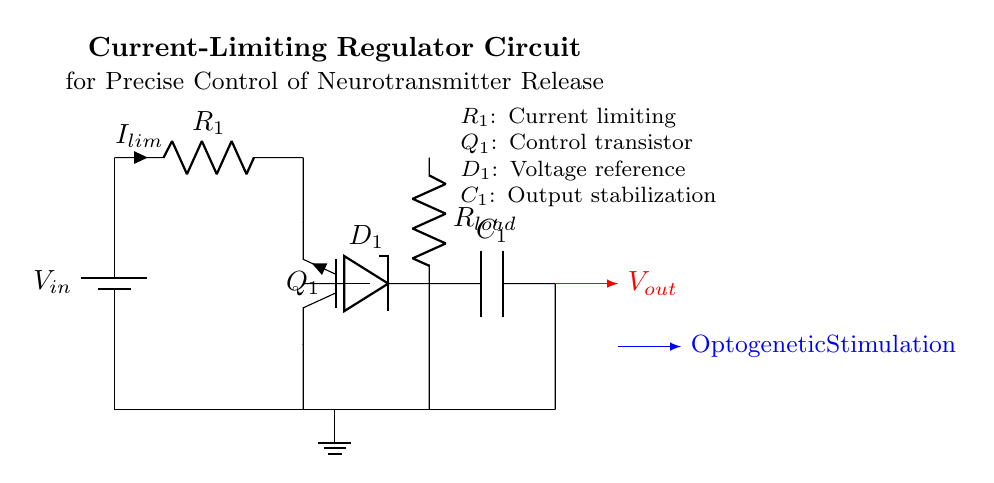What is the voltage source in this circuit? The voltage source in the circuit is labeled as V_in, indicating that it provides the input voltage to the rest of the circuit components.
Answer: V_in What component is used for current limiting? The current limiting component is labeled as R_1, which is a resistor placed in series to restrict the current flow through the circuit.
Answer: R_1 How many capacitors are present in this circuit? The diagram shows one capacitor, labeled C_1, which helps in output stabilization by filtering any voltage fluctuations at the output.
Answer: 1 What type of transistor is used in this regulator? The transistor used in the circuit is labeled as Q_1 and is specifically a NPN transistor, which is used for amplifying or switching in the circuit.
Answer: NPN What is the function of the Zener diode in this circuit? The Zener diode, labeled D_1, provides a stable reference voltage for the circuit, ensuring that the voltage remains constant despite variations in the input voltage or load conditions.
Answer: Voltage reference What is the purpose of the load resistor? The load resistor, labeled R_load, is responsible for simulating the load conditions under which the neurotransmitter release occurs, affecting current as needed for the optogenetic experiment.
Answer: Simulate load conditions What is the output of the regulator called? The output from the circuit is indicated as V_out, which is the regulated voltage supplied to control the neurotransmitter release in the experiments.
Answer: V_out 